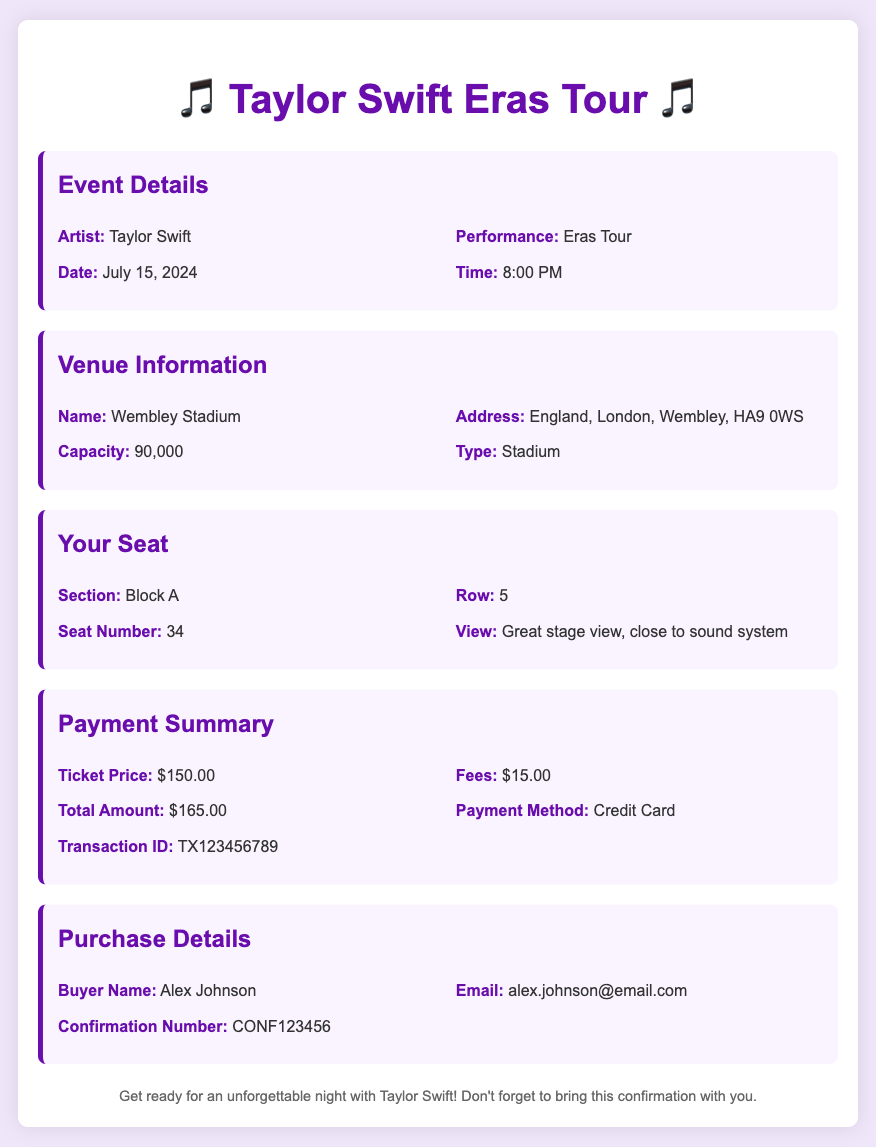What is the date of the concert? The date of the concert is listed as July 15, 2024.
Answer: July 15, 2024 What is the artist's name? The artist performing at the concert is Taylor Swift.
Answer: Taylor Swift How many seats does Wembley Stadium have? The capacity of Wembley Stadium is mentioned as 90,000.
Answer: 90,000 What section will you be seated in? The section information states that you will be seated in Block A.
Answer: Block A What is the total amount paid for the ticket? The total amount listed under the payment summary is $165.00.
Answer: $165.00 What is the performance title? The performance title for the event is Eras Tour.
Answer: Eras Tour What is the view type from your seat? The view from the seat is described as a great stage view, close to the sound system.
Answer: Great stage view, close to sound system Who is the buyer of the ticket? The buyer's name provided in the document is Alex Johnson.
Answer: Alex Johnson What payment method was used? The payment method indicated in the payment summary is Credit Card.
Answer: Credit Card 